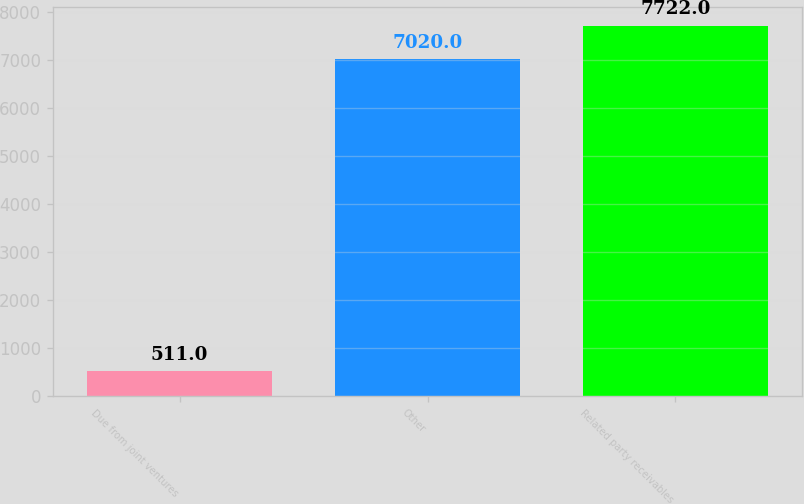<chart> <loc_0><loc_0><loc_500><loc_500><bar_chart><fcel>Due from joint ventures<fcel>Other<fcel>Related party receivables<nl><fcel>511<fcel>7020<fcel>7722<nl></chart> 